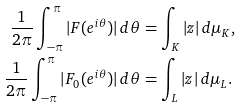Convert formula to latex. <formula><loc_0><loc_0><loc_500><loc_500>\frac { 1 } { 2 \pi } \int _ { - \pi } ^ { \pi } | F ( e ^ { i \theta } ) | \, d \theta & = \int _ { K } | z | \, d \mu _ { K } , \\ \frac { 1 } { 2 \pi } \int _ { - \pi } ^ { \pi } | F _ { 0 } ( e ^ { i \theta } ) | \, d \theta & = \int _ { L } | z | \, d \mu _ { L } .</formula> 